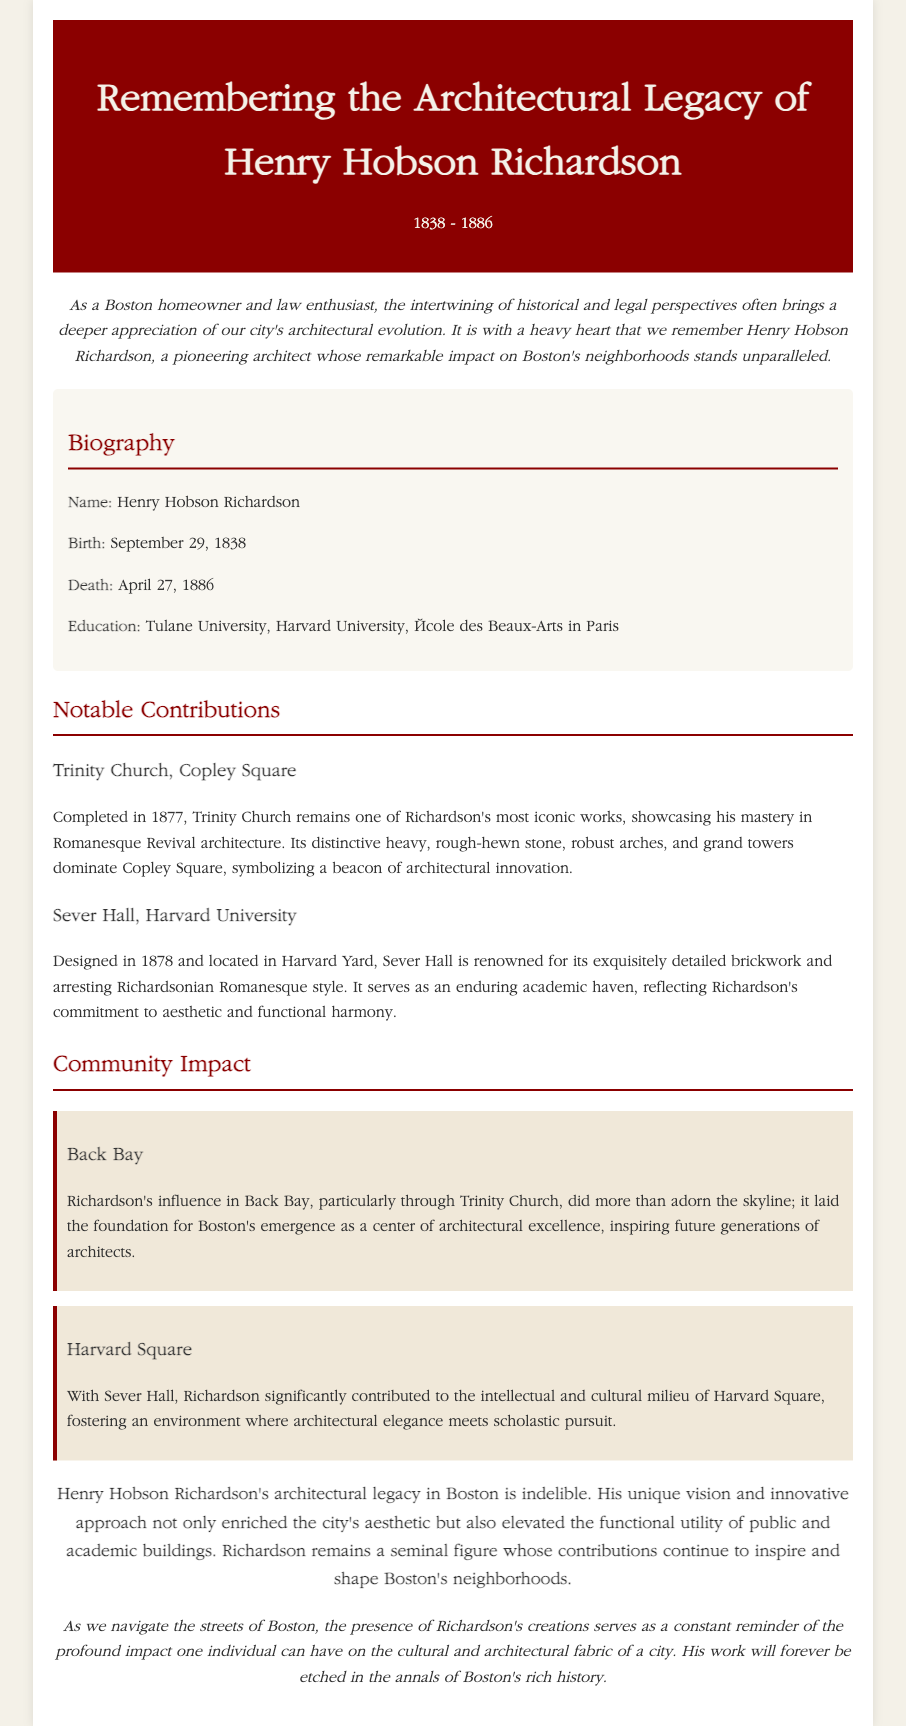what was Henry Hobson Richardson's birth date? The document states his birth date as September 29, 1838.
Answer: September 29, 1838 when did Henry Hobson Richardson die? The document specifies that he died on April 27, 1886.
Answer: April 27, 1886 what architectural style is Trinity Church known for? The document describes Trinity Church as showcasing Romanesque Revival architecture.
Answer: Romanesque Revival which university did Richardson attend besides Harvard? The document mentions Tulane University as another institution he attended.
Answer: Tulane University what is the name of the hall he designed at Harvard University? The document refers to the hall as Sever Hall.
Answer: Sever Hall how did Richardson's work influence Back Bay? The document states his influence laid the foundation for Boston's emergence as a center of architectural excellence.
Answer: Architectural excellence what does Trinity Church symbolize according to the document? The document mentions it symbolizes a beacon of architectural innovation.
Answer: Beacon of architectural innovation which year was Sever Hall completed? The document indicates that Sever Hall was designed in 1878.
Answer: 1878 how is Henry Hobson Richardson's legacy described in the closing paragraph? The document states his architectural legacy in Boston is indelible.
Answer: Indelible 